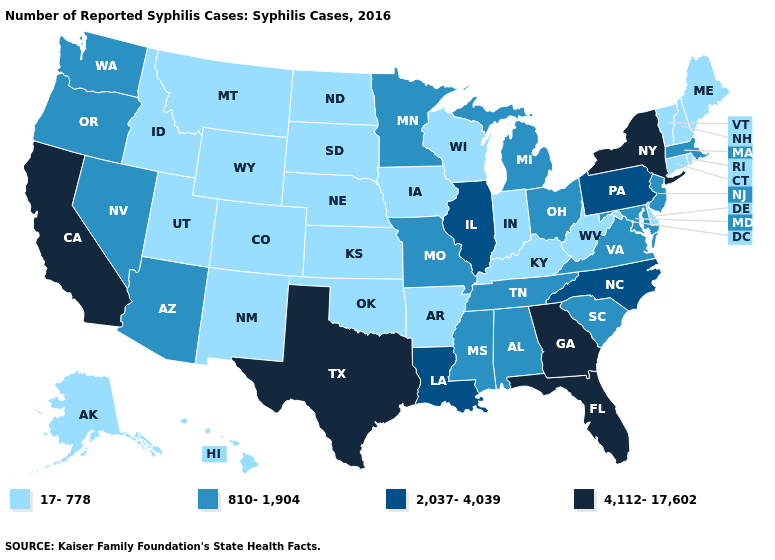Name the states that have a value in the range 2,037-4,039?
Quick response, please. Illinois, Louisiana, North Carolina, Pennsylvania. Which states hav the highest value in the MidWest?
Quick response, please. Illinois. Does the first symbol in the legend represent the smallest category?
Answer briefly. Yes. Among the states that border Tennessee , which have the lowest value?
Quick response, please. Arkansas, Kentucky. What is the highest value in the USA?
Be succinct. 4,112-17,602. Does the first symbol in the legend represent the smallest category?
Write a very short answer. Yes. Name the states that have a value in the range 2,037-4,039?
Concise answer only. Illinois, Louisiana, North Carolina, Pennsylvania. What is the value of Missouri?
Write a very short answer. 810-1,904. What is the value of Michigan?
Short answer required. 810-1,904. Name the states that have a value in the range 2,037-4,039?
Short answer required. Illinois, Louisiana, North Carolina, Pennsylvania. Name the states that have a value in the range 4,112-17,602?
Quick response, please. California, Florida, Georgia, New York, Texas. Among the states that border Idaho , does Wyoming have the highest value?
Short answer required. No. Name the states that have a value in the range 4,112-17,602?
Give a very brief answer. California, Florida, Georgia, New York, Texas. Name the states that have a value in the range 4,112-17,602?
Write a very short answer. California, Florida, Georgia, New York, Texas. 